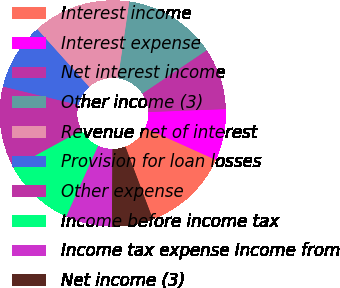Convert chart to OTSL. <chart><loc_0><loc_0><loc_500><loc_500><pie_chart><fcel>Interest income<fcel>Interest expense<fcel>Net interest income<fcel>Other income (3)<fcel>Revenue net of interest<fcel>Provision for loan losses<fcel>Other expense<fcel>Income before income tax<fcel>Income tax expense Income from<fcel>Net income (3)<nl><fcel>12.5%<fcel>7.35%<fcel>8.82%<fcel>13.24%<fcel>13.97%<fcel>9.56%<fcel>11.76%<fcel>10.29%<fcel>6.62%<fcel>5.88%<nl></chart> 